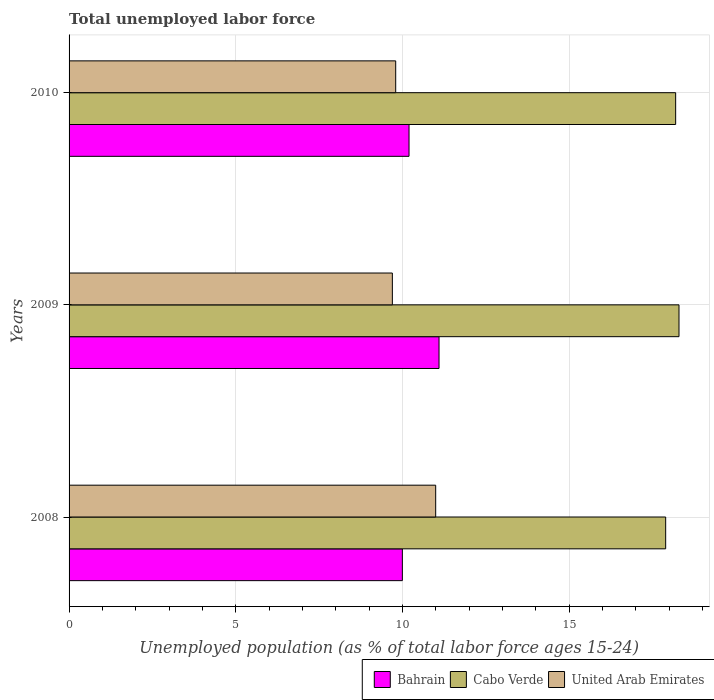How many different coloured bars are there?
Your answer should be very brief. 3. How many groups of bars are there?
Keep it short and to the point. 3. Are the number of bars on each tick of the Y-axis equal?
Your response must be concise. Yes. How many bars are there on the 2nd tick from the top?
Keep it short and to the point. 3. In how many cases, is the number of bars for a given year not equal to the number of legend labels?
Provide a succinct answer. 0. What is the percentage of unemployed population in in Bahrain in 2009?
Your answer should be compact. 11.1. Across all years, what is the maximum percentage of unemployed population in in United Arab Emirates?
Make the answer very short. 11. Across all years, what is the minimum percentage of unemployed population in in Bahrain?
Make the answer very short. 10. In which year was the percentage of unemployed population in in Cabo Verde maximum?
Offer a very short reply. 2009. In which year was the percentage of unemployed population in in Cabo Verde minimum?
Give a very brief answer. 2008. What is the total percentage of unemployed population in in Bahrain in the graph?
Give a very brief answer. 31.3. What is the difference between the percentage of unemployed population in in United Arab Emirates in 2008 and that in 2009?
Provide a short and direct response. 1.3. What is the difference between the percentage of unemployed population in in Bahrain in 2010 and the percentage of unemployed population in in Cabo Verde in 2009?
Your response must be concise. -8.1. What is the average percentage of unemployed population in in United Arab Emirates per year?
Give a very brief answer. 10.17. In the year 2010, what is the difference between the percentage of unemployed population in in Bahrain and percentage of unemployed population in in United Arab Emirates?
Keep it short and to the point. 0.4. What is the ratio of the percentage of unemployed population in in Bahrain in 2008 to that in 2010?
Your answer should be very brief. 0.98. Is the difference between the percentage of unemployed population in in Bahrain in 2008 and 2009 greater than the difference between the percentage of unemployed population in in United Arab Emirates in 2008 and 2009?
Provide a short and direct response. No. What is the difference between the highest and the second highest percentage of unemployed population in in Bahrain?
Keep it short and to the point. 0.9. What is the difference between the highest and the lowest percentage of unemployed population in in United Arab Emirates?
Offer a terse response. 1.3. What does the 2nd bar from the top in 2010 represents?
Your answer should be very brief. Cabo Verde. What does the 2nd bar from the bottom in 2009 represents?
Make the answer very short. Cabo Verde. How many bars are there?
Ensure brevity in your answer.  9. How many years are there in the graph?
Offer a terse response. 3. What is the difference between two consecutive major ticks on the X-axis?
Ensure brevity in your answer.  5. Where does the legend appear in the graph?
Offer a terse response. Bottom right. How many legend labels are there?
Your answer should be compact. 3. What is the title of the graph?
Provide a succinct answer. Total unemployed labor force. What is the label or title of the X-axis?
Ensure brevity in your answer.  Unemployed population (as % of total labor force ages 15-24). What is the label or title of the Y-axis?
Your answer should be compact. Years. What is the Unemployed population (as % of total labor force ages 15-24) in Bahrain in 2008?
Give a very brief answer. 10. What is the Unemployed population (as % of total labor force ages 15-24) of Cabo Verde in 2008?
Offer a very short reply. 17.9. What is the Unemployed population (as % of total labor force ages 15-24) in Bahrain in 2009?
Provide a short and direct response. 11.1. What is the Unemployed population (as % of total labor force ages 15-24) of Cabo Verde in 2009?
Provide a short and direct response. 18.3. What is the Unemployed population (as % of total labor force ages 15-24) in United Arab Emirates in 2009?
Keep it short and to the point. 9.7. What is the Unemployed population (as % of total labor force ages 15-24) of Bahrain in 2010?
Ensure brevity in your answer.  10.2. What is the Unemployed population (as % of total labor force ages 15-24) in Cabo Verde in 2010?
Ensure brevity in your answer.  18.2. What is the Unemployed population (as % of total labor force ages 15-24) of United Arab Emirates in 2010?
Your answer should be compact. 9.8. Across all years, what is the maximum Unemployed population (as % of total labor force ages 15-24) of Bahrain?
Your answer should be very brief. 11.1. Across all years, what is the maximum Unemployed population (as % of total labor force ages 15-24) in Cabo Verde?
Make the answer very short. 18.3. Across all years, what is the minimum Unemployed population (as % of total labor force ages 15-24) in Bahrain?
Make the answer very short. 10. Across all years, what is the minimum Unemployed population (as % of total labor force ages 15-24) in Cabo Verde?
Offer a very short reply. 17.9. Across all years, what is the minimum Unemployed population (as % of total labor force ages 15-24) in United Arab Emirates?
Provide a short and direct response. 9.7. What is the total Unemployed population (as % of total labor force ages 15-24) in Bahrain in the graph?
Offer a terse response. 31.3. What is the total Unemployed population (as % of total labor force ages 15-24) of Cabo Verde in the graph?
Your answer should be very brief. 54.4. What is the total Unemployed population (as % of total labor force ages 15-24) of United Arab Emirates in the graph?
Ensure brevity in your answer.  30.5. What is the difference between the Unemployed population (as % of total labor force ages 15-24) of United Arab Emirates in 2008 and that in 2010?
Your answer should be very brief. 1.2. What is the difference between the Unemployed population (as % of total labor force ages 15-24) of Cabo Verde in 2009 and that in 2010?
Offer a terse response. 0.1. What is the difference between the Unemployed population (as % of total labor force ages 15-24) of Bahrain in 2009 and the Unemployed population (as % of total labor force ages 15-24) of Cabo Verde in 2010?
Keep it short and to the point. -7.1. What is the difference between the Unemployed population (as % of total labor force ages 15-24) of Cabo Verde in 2009 and the Unemployed population (as % of total labor force ages 15-24) of United Arab Emirates in 2010?
Offer a very short reply. 8.5. What is the average Unemployed population (as % of total labor force ages 15-24) in Bahrain per year?
Provide a short and direct response. 10.43. What is the average Unemployed population (as % of total labor force ages 15-24) of Cabo Verde per year?
Your answer should be compact. 18.13. What is the average Unemployed population (as % of total labor force ages 15-24) in United Arab Emirates per year?
Your answer should be compact. 10.17. In the year 2008, what is the difference between the Unemployed population (as % of total labor force ages 15-24) of Bahrain and Unemployed population (as % of total labor force ages 15-24) of United Arab Emirates?
Your answer should be very brief. -1. In the year 2009, what is the difference between the Unemployed population (as % of total labor force ages 15-24) in Bahrain and Unemployed population (as % of total labor force ages 15-24) in United Arab Emirates?
Keep it short and to the point. 1.4. In the year 2009, what is the difference between the Unemployed population (as % of total labor force ages 15-24) in Cabo Verde and Unemployed population (as % of total labor force ages 15-24) in United Arab Emirates?
Your answer should be compact. 8.6. In the year 2010, what is the difference between the Unemployed population (as % of total labor force ages 15-24) of Bahrain and Unemployed population (as % of total labor force ages 15-24) of Cabo Verde?
Provide a succinct answer. -8. In the year 2010, what is the difference between the Unemployed population (as % of total labor force ages 15-24) in Bahrain and Unemployed population (as % of total labor force ages 15-24) in United Arab Emirates?
Ensure brevity in your answer.  0.4. In the year 2010, what is the difference between the Unemployed population (as % of total labor force ages 15-24) in Cabo Verde and Unemployed population (as % of total labor force ages 15-24) in United Arab Emirates?
Your answer should be very brief. 8.4. What is the ratio of the Unemployed population (as % of total labor force ages 15-24) of Bahrain in 2008 to that in 2009?
Make the answer very short. 0.9. What is the ratio of the Unemployed population (as % of total labor force ages 15-24) in Cabo Verde in 2008 to that in 2009?
Your response must be concise. 0.98. What is the ratio of the Unemployed population (as % of total labor force ages 15-24) in United Arab Emirates in 2008 to that in 2009?
Provide a short and direct response. 1.13. What is the ratio of the Unemployed population (as % of total labor force ages 15-24) of Bahrain in 2008 to that in 2010?
Provide a succinct answer. 0.98. What is the ratio of the Unemployed population (as % of total labor force ages 15-24) in Cabo Verde in 2008 to that in 2010?
Your answer should be very brief. 0.98. What is the ratio of the Unemployed population (as % of total labor force ages 15-24) in United Arab Emirates in 2008 to that in 2010?
Ensure brevity in your answer.  1.12. What is the ratio of the Unemployed population (as % of total labor force ages 15-24) in Bahrain in 2009 to that in 2010?
Offer a very short reply. 1.09. What is the ratio of the Unemployed population (as % of total labor force ages 15-24) of Cabo Verde in 2009 to that in 2010?
Your answer should be compact. 1.01. What is the ratio of the Unemployed population (as % of total labor force ages 15-24) of United Arab Emirates in 2009 to that in 2010?
Your answer should be very brief. 0.99. What is the difference between the highest and the second highest Unemployed population (as % of total labor force ages 15-24) in Bahrain?
Keep it short and to the point. 0.9. What is the difference between the highest and the second highest Unemployed population (as % of total labor force ages 15-24) of Cabo Verde?
Give a very brief answer. 0.1. What is the difference between the highest and the second highest Unemployed population (as % of total labor force ages 15-24) in United Arab Emirates?
Ensure brevity in your answer.  1.2. What is the difference between the highest and the lowest Unemployed population (as % of total labor force ages 15-24) in United Arab Emirates?
Ensure brevity in your answer.  1.3. 